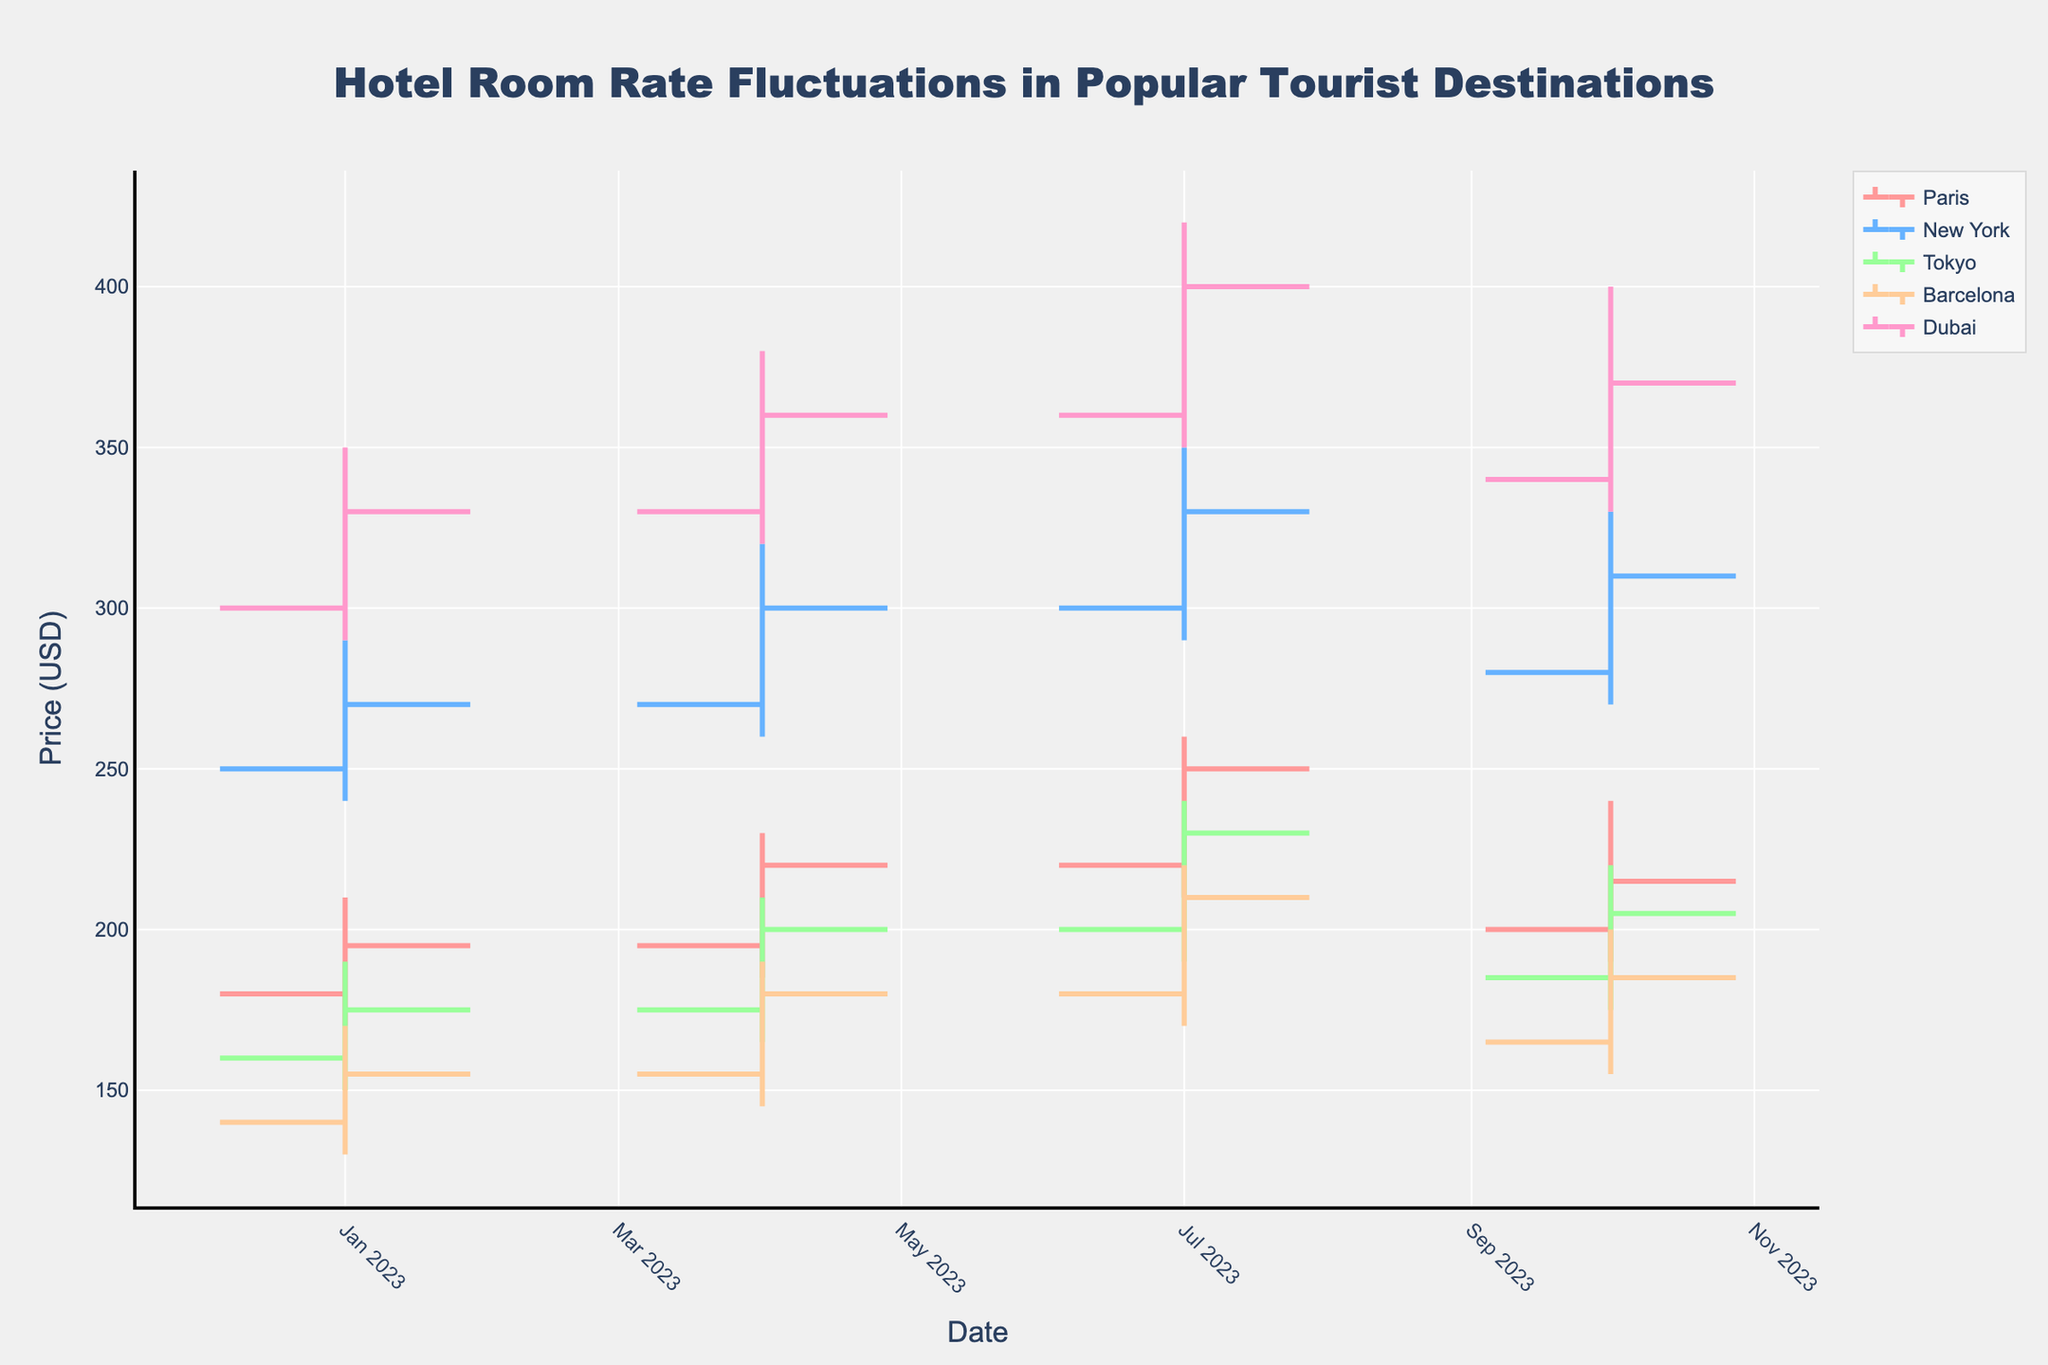How many cities are represented in the chart? By observing the different tracers in the plot, we can see the distinct colors and the legend indicating the city names.
Answer: 5 Which city has the highest closing rate in July? By looking at the July data points and comparing the closing values for each city, we can see New York has the highest closing rate.
Answer: New York What is the average opening rate for Paris in the first and last quarters of the year? Gather the opening rates for Paris in January (180) and October (200). The average is (180 + 200)/2 = 190.
Answer: 190 For which quarter did Dubai experience the highest volatility in rates? Volatility can be seen by the difference between the high and low rates. In July, the difference (420-350) is the largest at 70.
Answer: July How does Tokyo's closing rate change from April to July? Tokyo's closing rate in April is 200 and in July it is 230. The change is 230 - 200 = 30.
Answer: +30 Which city had the lowest closing rate in January? By looking at the closing rates of all cities in January, Barcelona's closing rate (155) is the lowest.
Answer: Barcelona Compare the highest room rate in New York and Dubai in April. Which one is higher and by how much? New York's highest rate in April is 320, whereas Dubai's is 380. The difference is 380 - 320 = 60, thus Dubai's rate is higher by 60 USD.
Answer: Dubai by 60 Which city shows a consistent increase in closing rates every quarter? By examining the closing rates across quarters, Dubai shows a consistent increase: 330 in January, 360 in April, 400 in July, and 370 in October. However, the October rate is not higher, so no city shows a consistent increase every quarter.
Answer: None Is the average closing rate in October higher for Tokyo or Paris? Tokyo's closing rate in October is 205 and Paris's is 215. The average can be directly compared: 215 is greater than 205.
Answer: Paris How did the hotel room rates in Barcelona change from January to July in terms of open and close values? In January, the open rate is 140 and the close is 155; in July, the open rate is 180 and the close is 210. The change is (180 - 140) = 40 for the open and (210 - 155) = 55 for the close.
Answer: Open: +40, Close: +55 